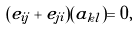<formula> <loc_0><loc_0><loc_500><loc_500>( e _ { i j } + e _ { j i } ) ( a _ { k l } ) = 0 ,</formula> 